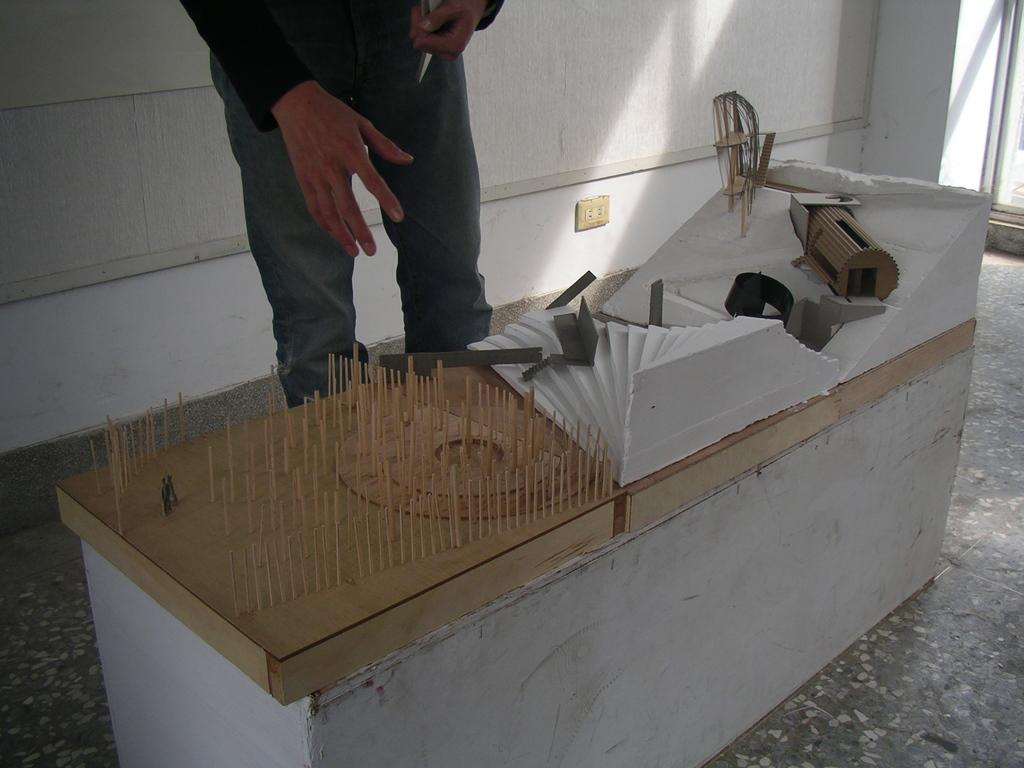What is the main subject in the image? There is a person standing in the image. What can be seen in front of the person? There are tools on a table in front of the person. What is located on the wall in the background? There is a plug board on the wall in the background. What is the color of the plug board? The plug board is white in color. Can you see a curtain in the image? There is no curtain present in the image. Is there a river visible in the image? There is no river visible in the image. 